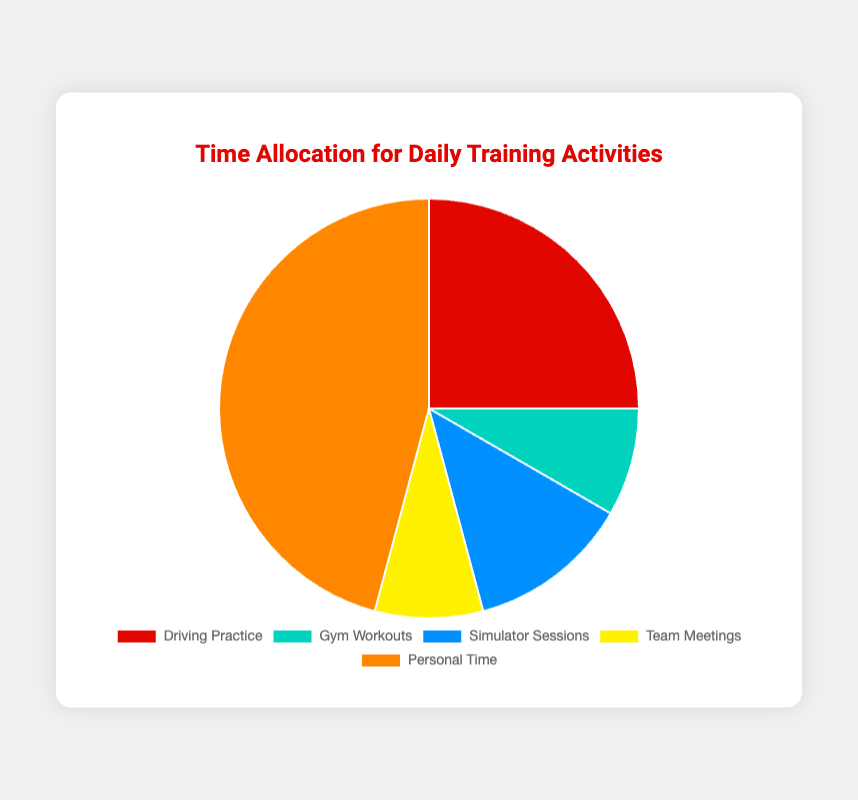How many total hours are spent on all activities? Add up all the provided hours: 6 (Driving Practice) + 2 (Gym Workouts) + 3 (Simulator Sessions) + 2 (Team Meetings) + 11 (Personal Time) = 24.
Answer: 24 Which activity takes up the most time? Personal Time is the activity with the highest number of hours, which is 11.
Answer: Personal Time What is the ratio of hours spent on Driving Practice to hours spent on Gym Workouts? Driving Practice has 6 hours and Gym Workouts has 2 hours. The ratio is 6:2, which simplifies to 3:1.
Answer: 3:1 How many more hours are spent on Personal Time compared to Simulator Sessions? Personal Time is 11 hours and Simulator Sessions are 3 hours. The difference is 11 - 3 = 8.
Answer: 8 What percentage of the total time is allocated to Team Meetings? Team Meetings are 2 hours in a total of 24 hours. The percentage is (2/24) * 100 ≈ 8.33%.
Answer: 8.33% Are more hours allocated to Gym Workouts or Simulator Sessions? Simulator Sessions have 3 hours, whereas Gym Workouts have 2 hours. Therefore, more hours are allocated to Simulator Sessions.
Answer: Simulator Sessions Combine the hours spent on Gym Workouts and Team Meetings. How does this compare to the hours spent on Simulator Sessions? Gym Workouts + Team Meetings = 2 + 2 = 4 hours. Simulator Sessions are 3 hours. 4 hours is greater than 3 hours.
Answer: 4 is greater Which activity occupies the smallest portion of the pie chart? Gym Workouts and Team Meetings both have 2 hours, which are the smallest values in the dataset.
Answer: Gym Workouts and Team Meetings If you were to equally redistribute the time spent on Gym Workouts and Team Meetings to Simulator Sessions, how many hours would Simulator Sessions have? Gym Workouts and Team Meetings together are 4 hours. Redistributing equally to Simulator Sessions: 3 (initial) + 4 = 7 hours.
Answer: 7 